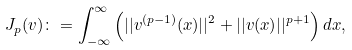Convert formula to latex. <formula><loc_0><loc_0><loc_500><loc_500>J _ { p } ( v ) \colon = \int _ { - \infty } ^ { \infty } \left ( | | v ^ { ( p - 1 ) } ( x ) | | ^ { 2 } + | | v ( x ) | | ^ { p + 1 } \right ) d x ,</formula> 